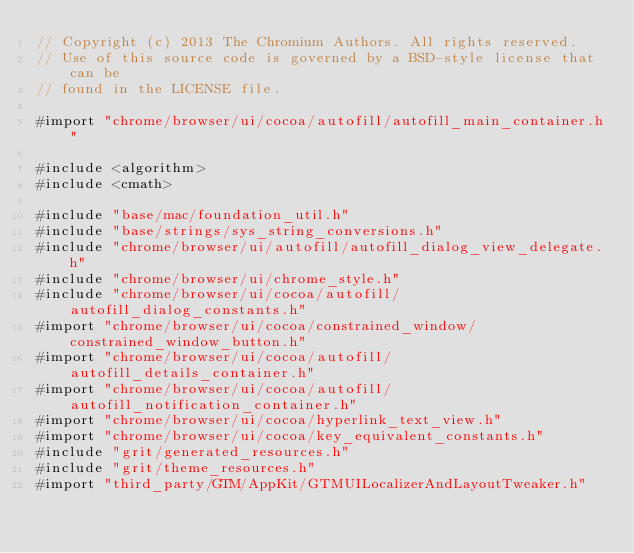Convert code to text. <code><loc_0><loc_0><loc_500><loc_500><_ObjectiveC_>// Copyright (c) 2013 The Chromium Authors. All rights reserved.
// Use of this source code is governed by a BSD-style license that can be
// found in the LICENSE file.

#import "chrome/browser/ui/cocoa/autofill/autofill_main_container.h"

#include <algorithm>
#include <cmath>

#include "base/mac/foundation_util.h"
#include "base/strings/sys_string_conversions.h"
#include "chrome/browser/ui/autofill/autofill_dialog_view_delegate.h"
#include "chrome/browser/ui/chrome_style.h"
#include "chrome/browser/ui/cocoa/autofill/autofill_dialog_constants.h"
#import "chrome/browser/ui/cocoa/constrained_window/constrained_window_button.h"
#import "chrome/browser/ui/cocoa/autofill/autofill_details_container.h"
#import "chrome/browser/ui/cocoa/autofill/autofill_notification_container.h"
#import "chrome/browser/ui/cocoa/hyperlink_text_view.h"
#import "chrome/browser/ui/cocoa/key_equivalent_constants.h"
#include "grit/generated_resources.h"
#include "grit/theme_resources.h"
#import "third_party/GTM/AppKit/GTMUILocalizerAndLayoutTweaker.h"</code> 